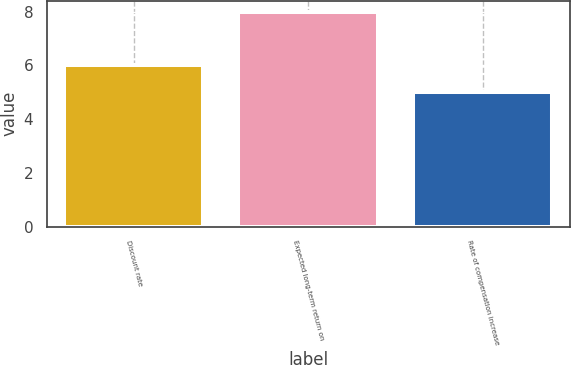Convert chart. <chart><loc_0><loc_0><loc_500><loc_500><bar_chart><fcel>Discount rate<fcel>Expected long-term return on<fcel>Rate of compensation increase<nl><fcel>6<fcel>8<fcel>5<nl></chart> 